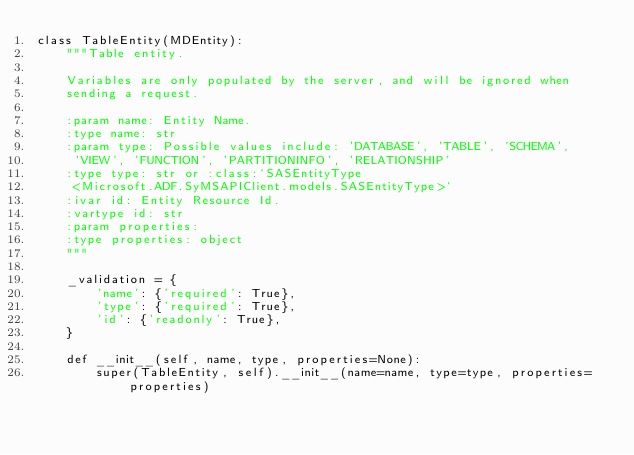Convert code to text. <code><loc_0><loc_0><loc_500><loc_500><_Python_>class TableEntity(MDEntity):
    """Table entity.

    Variables are only populated by the server, and will be ignored when
    sending a request.

    :param name: Entity Name.
    :type name: str
    :param type: Possible values include: 'DATABASE', 'TABLE', 'SCHEMA',
     'VIEW', 'FUNCTION', 'PARTITIONINFO', 'RELATIONSHIP'
    :type type: str or :class:`SASEntityType
     <Microsoft.ADF.SyMSAPIClient.models.SASEntityType>`
    :ivar id: Entity Resource Id.
    :vartype id: str
    :param properties:
    :type properties: object
    """ 

    _validation = {
        'name': {'required': True},
        'type': {'required': True},
        'id': {'readonly': True},
    }

    def __init__(self, name, type, properties=None):
        super(TableEntity, self).__init__(name=name, type=type, properties=properties)
</code> 